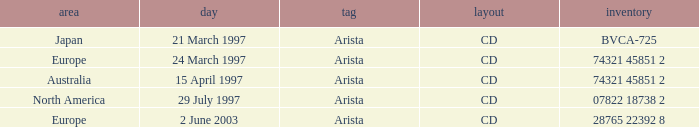What Label has the Region of Australia? Arista. 